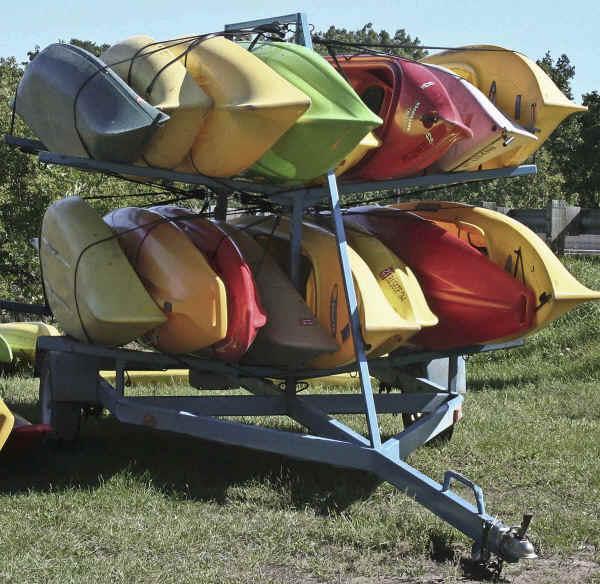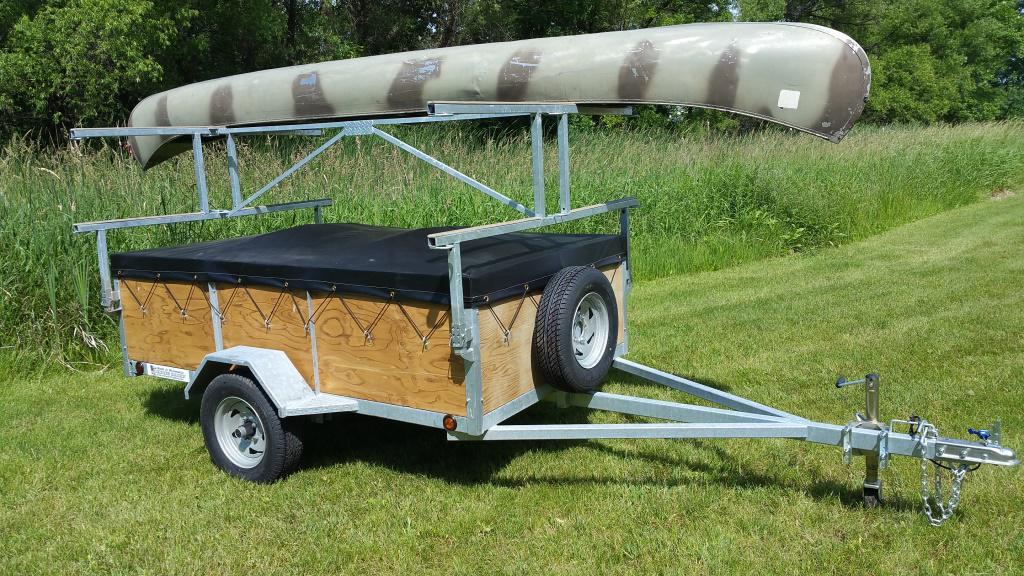The first image is the image on the left, the second image is the image on the right. Analyze the images presented: Is the assertion "Each image includes a rack containing at least three boats in bright solid colors." valid? Answer yes or no. No. 